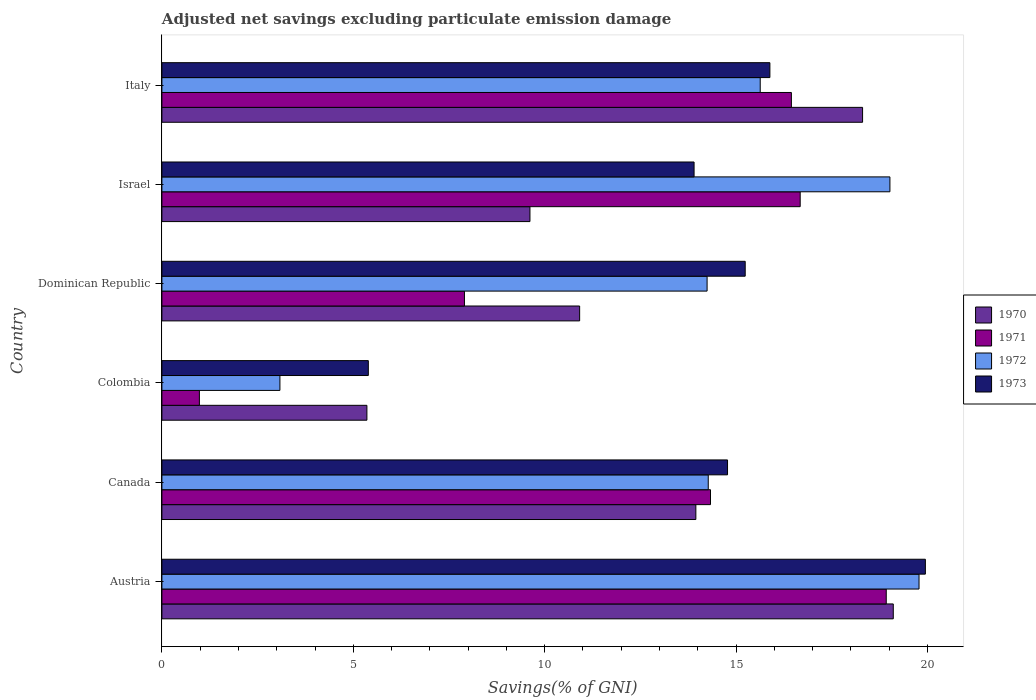How many different coloured bars are there?
Ensure brevity in your answer.  4. How many bars are there on the 3rd tick from the top?
Keep it short and to the point. 4. How many bars are there on the 1st tick from the bottom?
Keep it short and to the point. 4. What is the label of the 1st group of bars from the top?
Your response must be concise. Italy. In how many cases, is the number of bars for a given country not equal to the number of legend labels?
Your answer should be very brief. 0. What is the adjusted net savings in 1970 in Israel?
Make the answer very short. 9.61. Across all countries, what is the maximum adjusted net savings in 1972?
Offer a terse response. 19.78. Across all countries, what is the minimum adjusted net savings in 1972?
Offer a very short reply. 3.08. In which country was the adjusted net savings in 1971 maximum?
Your answer should be very brief. Austria. In which country was the adjusted net savings in 1972 minimum?
Your answer should be compact. Colombia. What is the total adjusted net savings in 1973 in the graph?
Make the answer very short. 85.14. What is the difference between the adjusted net savings in 1973 in Austria and that in Colombia?
Provide a short and direct response. 14.55. What is the difference between the adjusted net savings in 1971 in Dominican Republic and the adjusted net savings in 1972 in Israel?
Keep it short and to the point. -11.11. What is the average adjusted net savings in 1972 per country?
Make the answer very short. 14.34. What is the difference between the adjusted net savings in 1971 and adjusted net savings in 1970 in Austria?
Your response must be concise. -0.18. In how many countries, is the adjusted net savings in 1970 greater than 17 %?
Offer a terse response. 2. What is the ratio of the adjusted net savings in 1970 in Colombia to that in Dominican Republic?
Your answer should be compact. 0.49. Is the adjusted net savings in 1971 in Canada less than that in Israel?
Give a very brief answer. Yes. What is the difference between the highest and the second highest adjusted net savings in 1970?
Give a very brief answer. 0.8. What is the difference between the highest and the lowest adjusted net savings in 1973?
Offer a very short reply. 14.55. What does the 4th bar from the bottom in Austria represents?
Ensure brevity in your answer.  1973. Is it the case that in every country, the sum of the adjusted net savings in 1971 and adjusted net savings in 1972 is greater than the adjusted net savings in 1970?
Give a very brief answer. No. How many bars are there?
Your response must be concise. 24. Are the values on the major ticks of X-axis written in scientific E-notation?
Keep it short and to the point. No. Does the graph contain grids?
Offer a very short reply. No. How are the legend labels stacked?
Your answer should be compact. Vertical. What is the title of the graph?
Provide a short and direct response. Adjusted net savings excluding particulate emission damage. What is the label or title of the X-axis?
Your answer should be very brief. Savings(% of GNI). What is the label or title of the Y-axis?
Give a very brief answer. Country. What is the Savings(% of GNI) of 1970 in Austria?
Make the answer very short. 19.11. What is the Savings(% of GNI) in 1971 in Austria?
Keep it short and to the point. 18.92. What is the Savings(% of GNI) of 1972 in Austria?
Provide a short and direct response. 19.78. What is the Savings(% of GNI) of 1973 in Austria?
Ensure brevity in your answer.  19.94. What is the Savings(% of GNI) in 1970 in Canada?
Your answer should be very brief. 13.95. What is the Savings(% of GNI) in 1971 in Canada?
Give a very brief answer. 14.33. What is the Savings(% of GNI) in 1972 in Canada?
Keep it short and to the point. 14.27. What is the Savings(% of GNI) of 1973 in Canada?
Offer a very short reply. 14.78. What is the Savings(% of GNI) in 1970 in Colombia?
Ensure brevity in your answer.  5.36. What is the Savings(% of GNI) in 1971 in Colombia?
Keep it short and to the point. 0.98. What is the Savings(% of GNI) of 1972 in Colombia?
Your answer should be compact. 3.08. What is the Savings(% of GNI) of 1973 in Colombia?
Your response must be concise. 5.39. What is the Savings(% of GNI) in 1970 in Dominican Republic?
Offer a very short reply. 10.91. What is the Savings(% of GNI) of 1971 in Dominican Republic?
Your answer should be compact. 7.9. What is the Savings(% of GNI) in 1972 in Dominican Republic?
Offer a very short reply. 14.24. What is the Savings(% of GNI) in 1973 in Dominican Republic?
Your response must be concise. 15.24. What is the Savings(% of GNI) of 1970 in Israel?
Your response must be concise. 9.61. What is the Savings(% of GNI) of 1971 in Israel?
Offer a terse response. 16.67. What is the Savings(% of GNI) in 1972 in Israel?
Ensure brevity in your answer.  19.02. What is the Savings(% of GNI) in 1973 in Israel?
Your response must be concise. 13.9. What is the Savings(% of GNI) of 1970 in Italy?
Give a very brief answer. 18.3. What is the Savings(% of GNI) in 1971 in Italy?
Provide a short and direct response. 16.44. What is the Savings(% of GNI) in 1972 in Italy?
Make the answer very short. 15.63. What is the Savings(% of GNI) in 1973 in Italy?
Your response must be concise. 15.88. Across all countries, what is the maximum Savings(% of GNI) in 1970?
Give a very brief answer. 19.11. Across all countries, what is the maximum Savings(% of GNI) in 1971?
Give a very brief answer. 18.92. Across all countries, what is the maximum Savings(% of GNI) of 1972?
Your answer should be compact. 19.78. Across all countries, what is the maximum Savings(% of GNI) of 1973?
Give a very brief answer. 19.94. Across all countries, what is the minimum Savings(% of GNI) of 1970?
Keep it short and to the point. 5.36. Across all countries, what is the minimum Savings(% of GNI) in 1971?
Offer a terse response. 0.98. Across all countries, what is the minimum Savings(% of GNI) of 1972?
Your response must be concise. 3.08. Across all countries, what is the minimum Savings(% of GNI) of 1973?
Give a very brief answer. 5.39. What is the total Savings(% of GNI) of 1970 in the graph?
Your response must be concise. 77.24. What is the total Savings(% of GNI) of 1971 in the graph?
Provide a short and direct response. 75.25. What is the total Savings(% of GNI) in 1972 in the graph?
Make the answer very short. 86.02. What is the total Savings(% of GNI) in 1973 in the graph?
Keep it short and to the point. 85.14. What is the difference between the Savings(% of GNI) in 1970 in Austria and that in Canada?
Provide a short and direct response. 5.16. What is the difference between the Savings(% of GNI) in 1971 in Austria and that in Canada?
Provide a short and direct response. 4.59. What is the difference between the Savings(% of GNI) in 1972 in Austria and that in Canada?
Your answer should be compact. 5.51. What is the difference between the Savings(% of GNI) of 1973 in Austria and that in Canada?
Your answer should be compact. 5.17. What is the difference between the Savings(% of GNI) in 1970 in Austria and that in Colombia?
Your answer should be very brief. 13.75. What is the difference between the Savings(% of GNI) in 1971 in Austria and that in Colombia?
Offer a very short reply. 17.94. What is the difference between the Savings(% of GNI) of 1972 in Austria and that in Colombia?
Provide a short and direct response. 16.7. What is the difference between the Savings(% of GNI) of 1973 in Austria and that in Colombia?
Offer a terse response. 14.55. What is the difference between the Savings(% of GNI) of 1970 in Austria and that in Dominican Republic?
Provide a succinct answer. 8.19. What is the difference between the Savings(% of GNI) of 1971 in Austria and that in Dominican Republic?
Keep it short and to the point. 11.02. What is the difference between the Savings(% of GNI) in 1972 in Austria and that in Dominican Republic?
Ensure brevity in your answer.  5.54. What is the difference between the Savings(% of GNI) in 1973 in Austria and that in Dominican Republic?
Provide a short and direct response. 4.71. What is the difference between the Savings(% of GNI) of 1970 in Austria and that in Israel?
Offer a terse response. 9.49. What is the difference between the Savings(% of GNI) of 1971 in Austria and that in Israel?
Give a very brief answer. 2.25. What is the difference between the Savings(% of GNI) in 1972 in Austria and that in Israel?
Ensure brevity in your answer.  0.76. What is the difference between the Savings(% of GNI) in 1973 in Austria and that in Israel?
Ensure brevity in your answer.  6.04. What is the difference between the Savings(% of GNI) of 1970 in Austria and that in Italy?
Keep it short and to the point. 0.8. What is the difference between the Savings(% of GNI) of 1971 in Austria and that in Italy?
Your answer should be compact. 2.48. What is the difference between the Savings(% of GNI) in 1972 in Austria and that in Italy?
Offer a very short reply. 4.15. What is the difference between the Savings(% of GNI) of 1973 in Austria and that in Italy?
Your answer should be compact. 4.06. What is the difference between the Savings(% of GNI) in 1970 in Canada and that in Colombia?
Ensure brevity in your answer.  8.59. What is the difference between the Savings(% of GNI) in 1971 in Canada and that in Colombia?
Your answer should be compact. 13.35. What is the difference between the Savings(% of GNI) in 1972 in Canada and that in Colombia?
Keep it short and to the point. 11.19. What is the difference between the Savings(% of GNI) of 1973 in Canada and that in Colombia?
Provide a succinct answer. 9.38. What is the difference between the Savings(% of GNI) of 1970 in Canada and that in Dominican Republic?
Provide a short and direct response. 3.04. What is the difference between the Savings(% of GNI) of 1971 in Canada and that in Dominican Republic?
Keep it short and to the point. 6.43. What is the difference between the Savings(% of GNI) in 1972 in Canada and that in Dominican Republic?
Your answer should be very brief. 0.03. What is the difference between the Savings(% of GNI) in 1973 in Canada and that in Dominican Republic?
Your answer should be very brief. -0.46. What is the difference between the Savings(% of GNI) of 1970 in Canada and that in Israel?
Offer a terse response. 4.33. What is the difference between the Savings(% of GNI) in 1971 in Canada and that in Israel?
Provide a succinct answer. -2.34. What is the difference between the Savings(% of GNI) in 1972 in Canada and that in Israel?
Your response must be concise. -4.75. What is the difference between the Savings(% of GNI) in 1973 in Canada and that in Israel?
Provide a succinct answer. 0.87. What is the difference between the Savings(% of GNI) in 1970 in Canada and that in Italy?
Provide a short and direct response. -4.36. What is the difference between the Savings(% of GNI) of 1971 in Canada and that in Italy?
Your answer should be very brief. -2.11. What is the difference between the Savings(% of GNI) of 1972 in Canada and that in Italy?
Ensure brevity in your answer.  -1.36. What is the difference between the Savings(% of GNI) in 1973 in Canada and that in Italy?
Ensure brevity in your answer.  -1.11. What is the difference between the Savings(% of GNI) of 1970 in Colombia and that in Dominican Republic?
Provide a succinct answer. -5.56. What is the difference between the Savings(% of GNI) in 1971 in Colombia and that in Dominican Republic?
Keep it short and to the point. -6.92. What is the difference between the Savings(% of GNI) of 1972 in Colombia and that in Dominican Republic?
Your response must be concise. -11.16. What is the difference between the Savings(% of GNI) in 1973 in Colombia and that in Dominican Republic?
Ensure brevity in your answer.  -9.85. What is the difference between the Savings(% of GNI) in 1970 in Colombia and that in Israel?
Your answer should be compact. -4.26. What is the difference between the Savings(% of GNI) of 1971 in Colombia and that in Israel?
Your response must be concise. -15.7. What is the difference between the Savings(% of GNI) in 1972 in Colombia and that in Israel?
Provide a short and direct response. -15.94. What is the difference between the Savings(% of GNI) of 1973 in Colombia and that in Israel?
Ensure brevity in your answer.  -8.51. What is the difference between the Savings(% of GNI) in 1970 in Colombia and that in Italy?
Your response must be concise. -12.95. What is the difference between the Savings(% of GNI) of 1971 in Colombia and that in Italy?
Offer a terse response. -15.46. What is the difference between the Savings(% of GNI) of 1972 in Colombia and that in Italy?
Provide a short and direct response. -12.55. What is the difference between the Savings(% of GNI) in 1973 in Colombia and that in Italy?
Keep it short and to the point. -10.49. What is the difference between the Savings(% of GNI) in 1970 in Dominican Republic and that in Israel?
Provide a succinct answer. 1.3. What is the difference between the Savings(% of GNI) in 1971 in Dominican Republic and that in Israel?
Your answer should be very brief. -8.77. What is the difference between the Savings(% of GNI) of 1972 in Dominican Republic and that in Israel?
Make the answer very short. -4.78. What is the difference between the Savings(% of GNI) in 1973 in Dominican Republic and that in Israel?
Give a very brief answer. 1.34. What is the difference between the Savings(% of GNI) in 1970 in Dominican Republic and that in Italy?
Make the answer very short. -7.39. What is the difference between the Savings(% of GNI) of 1971 in Dominican Republic and that in Italy?
Your response must be concise. -8.54. What is the difference between the Savings(% of GNI) of 1972 in Dominican Republic and that in Italy?
Your answer should be compact. -1.39. What is the difference between the Savings(% of GNI) of 1973 in Dominican Republic and that in Italy?
Offer a terse response. -0.65. What is the difference between the Savings(% of GNI) in 1970 in Israel and that in Italy?
Provide a succinct answer. -8.69. What is the difference between the Savings(% of GNI) of 1971 in Israel and that in Italy?
Offer a terse response. 0.23. What is the difference between the Savings(% of GNI) in 1972 in Israel and that in Italy?
Offer a very short reply. 3.39. What is the difference between the Savings(% of GNI) in 1973 in Israel and that in Italy?
Provide a succinct answer. -1.98. What is the difference between the Savings(% of GNI) in 1970 in Austria and the Savings(% of GNI) in 1971 in Canada?
Your response must be concise. 4.77. What is the difference between the Savings(% of GNI) in 1970 in Austria and the Savings(% of GNI) in 1972 in Canada?
Your response must be concise. 4.83. What is the difference between the Savings(% of GNI) in 1970 in Austria and the Savings(% of GNI) in 1973 in Canada?
Offer a terse response. 4.33. What is the difference between the Savings(% of GNI) of 1971 in Austria and the Savings(% of GNI) of 1972 in Canada?
Provide a short and direct response. 4.65. What is the difference between the Savings(% of GNI) in 1971 in Austria and the Savings(% of GNI) in 1973 in Canada?
Make the answer very short. 4.15. What is the difference between the Savings(% of GNI) in 1972 in Austria and the Savings(% of GNI) in 1973 in Canada?
Give a very brief answer. 5. What is the difference between the Savings(% of GNI) of 1970 in Austria and the Savings(% of GNI) of 1971 in Colombia?
Your response must be concise. 18.13. What is the difference between the Savings(% of GNI) in 1970 in Austria and the Savings(% of GNI) in 1972 in Colombia?
Your response must be concise. 16.02. What is the difference between the Savings(% of GNI) of 1970 in Austria and the Savings(% of GNI) of 1973 in Colombia?
Offer a terse response. 13.71. What is the difference between the Savings(% of GNI) in 1971 in Austria and the Savings(% of GNI) in 1972 in Colombia?
Your answer should be very brief. 15.84. What is the difference between the Savings(% of GNI) of 1971 in Austria and the Savings(% of GNI) of 1973 in Colombia?
Give a very brief answer. 13.53. What is the difference between the Savings(% of GNI) in 1972 in Austria and the Savings(% of GNI) in 1973 in Colombia?
Provide a succinct answer. 14.39. What is the difference between the Savings(% of GNI) of 1970 in Austria and the Savings(% of GNI) of 1971 in Dominican Republic?
Provide a succinct answer. 11.2. What is the difference between the Savings(% of GNI) of 1970 in Austria and the Savings(% of GNI) of 1972 in Dominican Republic?
Make the answer very short. 4.86. What is the difference between the Savings(% of GNI) in 1970 in Austria and the Savings(% of GNI) in 1973 in Dominican Republic?
Your answer should be compact. 3.87. What is the difference between the Savings(% of GNI) in 1971 in Austria and the Savings(% of GNI) in 1972 in Dominican Republic?
Your answer should be compact. 4.68. What is the difference between the Savings(% of GNI) of 1971 in Austria and the Savings(% of GNI) of 1973 in Dominican Republic?
Offer a very short reply. 3.68. What is the difference between the Savings(% of GNI) in 1972 in Austria and the Savings(% of GNI) in 1973 in Dominican Republic?
Your answer should be very brief. 4.54. What is the difference between the Savings(% of GNI) of 1970 in Austria and the Savings(% of GNI) of 1971 in Israel?
Give a very brief answer. 2.43. What is the difference between the Savings(% of GNI) of 1970 in Austria and the Savings(% of GNI) of 1972 in Israel?
Give a very brief answer. 0.09. What is the difference between the Savings(% of GNI) in 1970 in Austria and the Savings(% of GNI) in 1973 in Israel?
Your response must be concise. 5.2. What is the difference between the Savings(% of GNI) of 1971 in Austria and the Savings(% of GNI) of 1972 in Israel?
Provide a succinct answer. -0.1. What is the difference between the Savings(% of GNI) in 1971 in Austria and the Savings(% of GNI) in 1973 in Israel?
Give a very brief answer. 5.02. What is the difference between the Savings(% of GNI) of 1972 in Austria and the Savings(% of GNI) of 1973 in Israel?
Your answer should be very brief. 5.88. What is the difference between the Savings(% of GNI) in 1970 in Austria and the Savings(% of GNI) in 1971 in Italy?
Offer a terse response. 2.66. What is the difference between the Savings(% of GNI) in 1970 in Austria and the Savings(% of GNI) in 1972 in Italy?
Provide a short and direct response. 3.48. What is the difference between the Savings(% of GNI) in 1970 in Austria and the Savings(% of GNI) in 1973 in Italy?
Make the answer very short. 3.22. What is the difference between the Savings(% of GNI) of 1971 in Austria and the Savings(% of GNI) of 1972 in Italy?
Give a very brief answer. 3.29. What is the difference between the Savings(% of GNI) in 1971 in Austria and the Savings(% of GNI) in 1973 in Italy?
Your answer should be very brief. 3.04. What is the difference between the Savings(% of GNI) in 1972 in Austria and the Savings(% of GNI) in 1973 in Italy?
Make the answer very short. 3.9. What is the difference between the Savings(% of GNI) in 1970 in Canada and the Savings(% of GNI) in 1971 in Colombia?
Give a very brief answer. 12.97. What is the difference between the Savings(% of GNI) in 1970 in Canada and the Savings(% of GNI) in 1972 in Colombia?
Offer a very short reply. 10.87. What is the difference between the Savings(% of GNI) of 1970 in Canada and the Savings(% of GNI) of 1973 in Colombia?
Offer a very short reply. 8.56. What is the difference between the Savings(% of GNI) in 1971 in Canada and the Savings(% of GNI) in 1972 in Colombia?
Offer a terse response. 11.25. What is the difference between the Savings(% of GNI) in 1971 in Canada and the Savings(% of GNI) in 1973 in Colombia?
Provide a succinct answer. 8.94. What is the difference between the Savings(% of GNI) of 1972 in Canada and the Savings(% of GNI) of 1973 in Colombia?
Make the answer very short. 8.88. What is the difference between the Savings(% of GNI) of 1970 in Canada and the Savings(% of GNI) of 1971 in Dominican Republic?
Your answer should be very brief. 6.05. What is the difference between the Savings(% of GNI) in 1970 in Canada and the Savings(% of GNI) in 1972 in Dominican Republic?
Provide a short and direct response. -0.29. What is the difference between the Savings(% of GNI) in 1970 in Canada and the Savings(% of GNI) in 1973 in Dominican Republic?
Keep it short and to the point. -1.29. What is the difference between the Savings(% of GNI) in 1971 in Canada and the Savings(% of GNI) in 1972 in Dominican Republic?
Your answer should be compact. 0.09. What is the difference between the Savings(% of GNI) in 1971 in Canada and the Savings(% of GNI) in 1973 in Dominican Republic?
Keep it short and to the point. -0.91. What is the difference between the Savings(% of GNI) of 1972 in Canada and the Savings(% of GNI) of 1973 in Dominican Republic?
Provide a succinct answer. -0.97. What is the difference between the Savings(% of GNI) in 1970 in Canada and the Savings(% of GNI) in 1971 in Israel?
Offer a very short reply. -2.73. What is the difference between the Savings(% of GNI) of 1970 in Canada and the Savings(% of GNI) of 1972 in Israel?
Ensure brevity in your answer.  -5.07. What is the difference between the Savings(% of GNI) in 1970 in Canada and the Savings(% of GNI) in 1973 in Israel?
Provide a succinct answer. 0.05. What is the difference between the Savings(% of GNI) of 1971 in Canada and the Savings(% of GNI) of 1972 in Israel?
Provide a succinct answer. -4.69. What is the difference between the Savings(% of GNI) in 1971 in Canada and the Savings(% of GNI) in 1973 in Israel?
Provide a short and direct response. 0.43. What is the difference between the Savings(% of GNI) in 1972 in Canada and the Savings(% of GNI) in 1973 in Israel?
Provide a succinct answer. 0.37. What is the difference between the Savings(% of GNI) of 1970 in Canada and the Savings(% of GNI) of 1971 in Italy?
Your answer should be very brief. -2.5. What is the difference between the Savings(% of GNI) in 1970 in Canada and the Savings(% of GNI) in 1972 in Italy?
Provide a succinct answer. -1.68. What is the difference between the Savings(% of GNI) in 1970 in Canada and the Savings(% of GNI) in 1973 in Italy?
Offer a very short reply. -1.93. What is the difference between the Savings(% of GNI) in 1971 in Canada and the Savings(% of GNI) in 1972 in Italy?
Offer a very short reply. -1.3. What is the difference between the Savings(% of GNI) in 1971 in Canada and the Savings(% of GNI) in 1973 in Italy?
Your response must be concise. -1.55. What is the difference between the Savings(% of GNI) of 1972 in Canada and the Savings(% of GNI) of 1973 in Italy?
Your answer should be very brief. -1.61. What is the difference between the Savings(% of GNI) of 1970 in Colombia and the Savings(% of GNI) of 1971 in Dominican Republic?
Your answer should be very brief. -2.55. What is the difference between the Savings(% of GNI) in 1970 in Colombia and the Savings(% of GNI) in 1972 in Dominican Republic?
Your answer should be compact. -8.89. What is the difference between the Savings(% of GNI) in 1970 in Colombia and the Savings(% of GNI) in 1973 in Dominican Republic?
Provide a short and direct response. -9.88. What is the difference between the Savings(% of GNI) of 1971 in Colombia and the Savings(% of GNI) of 1972 in Dominican Republic?
Make the answer very short. -13.26. What is the difference between the Savings(% of GNI) of 1971 in Colombia and the Savings(% of GNI) of 1973 in Dominican Republic?
Keep it short and to the point. -14.26. What is the difference between the Savings(% of GNI) of 1972 in Colombia and the Savings(% of GNI) of 1973 in Dominican Republic?
Offer a very short reply. -12.15. What is the difference between the Savings(% of GNI) of 1970 in Colombia and the Savings(% of GNI) of 1971 in Israel?
Offer a very short reply. -11.32. What is the difference between the Savings(% of GNI) of 1970 in Colombia and the Savings(% of GNI) of 1972 in Israel?
Provide a short and direct response. -13.66. What is the difference between the Savings(% of GNI) of 1970 in Colombia and the Savings(% of GNI) of 1973 in Israel?
Make the answer very short. -8.55. What is the difference between the Savings(% of GNI) of 1971 in Colombia and the Savings(% of GNI) of 1972 in Israel?
Give a very brief answer. -18.04. What is the difference between the Savings(% of GNI) in 1971 in Colombia and the Savings(% of GNI) in 1973 in Israel?
Your response must be concise. -12.92. What is the difference between the Savings(% of GNI) in 1972 in Colombia and the Savings(% of GNI) in 1973 in Israel?
Your answer should be compact. -10.82. What is the difference between the Savings(% of GNI) of 1970 in Colombia and the Savings(% of GNI) of 1971 in Italy?
Provide a short and direct response. -11.09. What is the difference between the Savings(% of GNI) of 1970 in Colombia and the Savings(% of GNI) of 1972 in Italy?
Provide a short and direct response. -10.27. What is the difference between the Savings(% of GNI) in 1970 in Colombia and the Savings(% of GNI) in 1973 in Italy?
Keep it short and to the point. -10.53. What is the difference between the Savings(% of GNI) of 1971 in Colombia and the Savings(% of GNI) of 1972 in Italy?
Make the answer very short. -14.65. What is the difference between the Savings(% of GNI) of 1971 in Colombia and the Savings(% of GNI) of 1973 in Italy?
Provide a short and direct response. -14.9. What is the difference between the Savings(% of GNI) of 1972 in Colombia and the Savings(% of GNI) of 1973 in Italy?
Keep it short and to the point. -12.8. What is the difference between the Savings(% of GNI) of 1970 in Dominican Republic and the Savings(% of GNI) of 1971 in Israel?
Your answer should be very brief. -5.76. What is the difference between the Savings(% of GNI) of 1970 in Dominican Republic and the Savings(% of GNI) of 1972 in Israel?
Provide a short and direct response. -8.11. What is the difference between the Savings(% of GNI) of 1970 in Dominican Republic and the Savings(% of GNI) of 1973 in Israel?
Give a very brief answer. -2.99. What is the difference between the Savings(% of GNI) of 1971 in Dominican Republic and the Savings(% of GNI) of 1972 in Israel?
Your answer should be very brief. -11.11. What is the difference between the Savings(% of GNI) in 1971 in Dominican Republic and the Savings(% of GNI) in 1973 in Israel?
Offer a terse response. -6. What is the difference between the Savings(% of GNI) in 1972 in Dominican Republic and the Savings(% of GNI) in 1973 in Israel?
Make the answer very short. 0.34. What is the difference between the Savings(% of GNI) in 1970 in Dominican Republic and the Savings(% of GNI) in 1971 in Italy?
Your answer should be very brief. -5.53. What is the difference between the Savings(% of GNI) in 1970 in Dominican Republic and the Savings(% of GNI) in 1972 in Italy?
Give a very brief answer. -4.72. What is the difference between the Savings(% of GNI) in 1970 in Dominican Republic and the Savings(% of GNI) in 1973 in Italy?
Provide a short and direct response. -4.97. What is the difference between the Savings(% of GNI) in 1971 in Dominican Republic and the Savings(% of GNI) in 1972 in Italy?
Keep it short and to the point. -7.73. What is the difference between the Savings(% of GNI) in 1971 in Dominican Republic and the Savings(% of GNI) in 1973 in Italy?
Make the answer very short. -7.98. What is the difference between the Savings(% of GNI) of 1972 in Dominican Republic and the Savings(% of GNI) of 1973 in Italy?
Your answer should be very brief. -1.64. What is the difference between the Savings(% of GNI) of 1970 in Israel and the Savings(% of GNI) of 1971 in Italy?
Your answer should be very brief. -6.83. What is the difference between the Savings(% of GNI) in 1970 in Israel and the Savings(% of GNI) in 1972 in Italy?
Ensure brevity in your answer.  -6.02. What is the difference between the Savings(% of GNI) of 1970 in Israel and the Savings(% of GNI) of 1973 in Italy?
Offer a very short reply. -6.27. What is the difference between the Savings(% of GNI) in 1971 in Israel and the Savings(% of GNI) in 1972 in Italy?
Ensure brevity in your answer.  1.04. What is the difference between the Savings(% of GNI) in 1971 in Israel and the Savings(% of GNI) in 1973 in Italy?
Your answer should be very brief. 0.79. What is the difference between the Savings(% of GNI) of 1972 in Israel and the Savings(% of GNI) of 1973 in Italy?
Offer a terse response. 3.14. What is the average Savings(% of GNI) of 1970 per country?
Your answer should be compact. 12.87. What is the average Savings(% of GNI) of 1971 per country?
Your answer should be compact. 12.54. What is the average Savings(% of GNI) of 1972 per country?
Give a very brief answer. 14.34. What is the average Savings(% of GNI) in 1973 per country?
Your answer should be compact. 14.19. What is the difference between the Savings(% of GNI) of 1970 and Savings(% of GNI) of 1971 in Austria?
Keep it short and to the point. 0.18. What is the difference between the Savings(% of GNI) in 1970 and Savings(% of GNI) in 1972 in Austria?
Your answer should be compact. -0.67. What is the difference between the Savings(% of GNI) of 1970 and Savings(% of GNI) of 1973 in Austria?
Give a very brief answer. -0.84. What is the difference between the Savings(% of GNI) in 1971 and Savings(% of GNI) in 1972 in Austria?
Provide a short and direct response. -0.86. What is the difference between the Savings(% of GNI) of 1971 and Savings(% of GNI) of 1973 in Austria?
Make the answer very short. -1.02. What is the difference between the Savings(% of GNI) of 1972 and Savings(% of GNI) of 1973 in Austria?
Make the answer very short. -0.17. What is the difference between the Savings(% of GNI) of 1970 and Savings(% of GNI) of 1971 in Canada?
Make the answer very short. -0.38. What is the difference between the Savings(% of GNI) of 1970 and Savings(% of GNI) of 1972 in Canada?
Provide a succinct answer. -0.32. What is the difference between the Savings(% of GNI) of 1970 and Savings(% of GNI) of 1973 in Canada?
Provide a succinct answer. -0.83. What is the difference between the Savings(% of GNI) of 1971 and Savings(% of GNI) of 1972 in Canada?
Ensure brevity in your answer.  0.06. What is the difference between the Savings(% of GNI) in 1971 and Savings(% of GNI) in 1973 in Canada?
Your response must be concise. -0.45. What is the difference between the Savings(% of GNI) in 1972 and Savings(% of GNI) in 1973 in Canada?
Make the answer very short. -0.5. What is the difference between the Savings(% of GNI) of 1970 and Savings(% of GNI) of 1971 in Colombia?
Offer a very short reply. 4.38. What is the difference between the Savings(% of GNI) in 1970 and Savings(% of GNI) in 1972 in Colombia?
Keep it short and to the point. 2.27. What is the difference between the Savings(% of GNI) of 1970 and Savings(% of GNI) of 1973 in Colombia?
Offer a very short reply. -0.04. What is the difference between the Savings(% of GNI) in 1971 and Savings(% of GNI) in 1972 in Colombia?
Keep it short and to the point. -2.1. What is the difference between the Savings(% of GNI) of 1971 and Savings(% of GNI) of 1973 in Colombia?
Keep it short and to the point. -4.41. What is the difference between the Savings(% of GNI) in 1972 and Savings(% of GNI) in 1973 in Colombia?
Your answer should be very brief. -2.31. What is the difference between the Savings(% of GNI) in 1970 and Savings(% of GNI) in 1971 in Dominican Republic?
Provide a short and direct response. 3.01. What is the difference between the Savings(% of GNI) of 1970 and Savings(% of GNI) of 1972 in Dominican Republic?
Make the answer very short. -3.33. What is the difference between the Savings(% of GNI) of 1970 and Savings(% of GNI) of 1973 in Dominican Republic?
Your answer should be compact. -4.33. What is the difference between the Savings(% of GNI) of 1971 and Savings(% of GNI) of 1972 in Dominican Republic?
Your answer should be compact. -6.34. What is the difference between the Savings(% of GNI) in 1971 and Savings(% of GNI) in 1973 in Dominican Republic?
Keep it short and to the point. -7.33. What is the difference between the Savings(% of GNI) in 1972 and Savings(% of GNI) in 1973 in Dominican Republic?
Provide a succinct answer. -1. What is the difference between the Savings(% of GNI) in 1970 and Savings(% of GNI) in 1971 in Israel?
Offer a terse response. -7.06. What is the difference between the Savings(% of GNI) in 1970 and Savings(% of GNI) in 1972 in Israel?
Offer a terse response. -9.4. What is the difference between the Savings(% of GNI) in 1970 and Savings(% of GNI) in 1973 in Israel?
Ensure brevity in your answer.  -4.29. What is the difference between the Savings(% of GNI) of 1971 and Savings(% of GNI) of 1972 in Israel?
Ensure brevity in your answer.  -2.34. What is the difference between the Savings(% of GNI) in 1971 and Savings(% of GNI) in 1973 in Israel?
Ensure brevity in your answer.  2.77. What is the difference between the Savings(% of GNI) in 1972 and Savings(% of GNI) in 1973 in Israel?
Provide a short and direct response. 5.12. What is the difference between the Savings(% of GNI) of 1970 and Savings(% of GNI) of 1971 in Italy?
Your response must be concise. 1.86. What is the difference between the Savings(% of GNI) in 1970 and Savings(% of GNI) in 1972 in Italy?
Your answer should be compact. 2.67. What is the difference between the Savings(% of GNI) in 1970 and Savings(% of GNI) in 1973 in Italy?
Your response must be concise. 2.42. What is the difference between the Savings(% of GNI) of 1971 and Savings(% of GNI) of 1972 in Italy?
Give a very brief answer. 0.81. What is the difference between the Savings(% of GNI) in 1971 and Savings(% of GNI) in 1973 in Italy?
Make the answer very short. 0.56. What is the difference between the Savings(% of GNI) of 1972 and Savings(% of GNI) of 1973 in Italy?
Ensure brevity in your answer.  -0.25. What is the ratio of the Savings(% of GNI) in 1970 in Austria to that in Canada?
Your answer should be very brief. 1.37. What is the ratio of the Savings(% of GNI) of 1971 in Austria to that in Canada?
Your response must be concise. 1.32. What is the ratio of the Savings(% of GNI) in 1972 in Austria to that in Canada?
Offer a very short reply. 1.39. What is the ratio of the Savings(% of GNI) of 1973 in Austria to that in Canada?
Your answer should be very brief. 1.35. What is the ratio of the Savings(% of GNI) in 1970 in Austria to that in Colombia?
Offer a very short reply. 3.57. What is the ratio of the Savings(% of GNI) in 1971 in Austria to that in Colombia?
Keep it short and to the point. 19.32. What is the ratio of the Savings(% of GNI) in 1972 in Austria to that in Colombia?
Offer a terse response. 6.42. What is the ratio of the Savings(% of GNI) in 1973 in Austria to that in Colombia?
Offer a very short reply. 3.7. What is the ratio of the Savings(% of GNI) in 1970 in Austria to that in Dominican Republic?
Your answer should be compact. 1.75. What is the ratio of the Savings(% of GNI) in 1971 in Austria to that in Dominican Republic?
Ensure brevity in your answer.  2.39. What is the ratio of the Savings(% of GNI) in 1972 in Austria to that in Dominican Republic?
Provide a succinct answer. 1.39. What is the ratio of the Savings(% of GNI) of 1973 in Austria to that in Dominican Republic?
Provide a succinct answer. 1.31. What is the ratio of the Savings(% of GNI) in 1970 in Austria to that in Israel?
Your answer should be compact. 1.99. What is the ratio of the Savings(% of GNI) of 1971 in Austria to that in Israel?
Ensure brevity in your answer.  1.13. What is the ratio of the Savings(% of GNI) in 1972 in Austria to that in Israel?
Your answer should be very brief. 1.04. What is the ratio of the Savings(% of GNI) in 1973 in Austria to that in Israel?
Ensure brevity in your answer.  1.43. What is the ratio of the Savings(% of GNI) in 1970 in Austria to that in Italy?
Provide a succinct answer. 1.04. What is the ratio of the Savings(% of GNI) of 1971 in Austria to that in Italy?
Keep it short and to the point. 1.15. What is the ratio of the Savings(% of GNI) in 1972 in Austria to that in Italy?
Provide a short and direct response. 1.27. What is the ratio of the Savings(% of GNI) in 1973 in Austria to that in Italy?
Your answer should be very brief. 1.26. What is the ratio of the Savings(% of GNI) of 1970 in Canada to that in Colombia?
Your answer should be very brief. 2.6. What is the ratio of the Savings(% of GNI) in 1971 in Canada to that in Colombia?
Your answer should be very brief. 14.64. What is the ratio of the Savings(% of GNI) of 1972 in Canada to that in Colombia?
Make the answer very short. 4.63. What is the ratio of the Savings(% of GNI) of 1973 in Canada to that in Colombia?
Provide a short and direct response. 2.74. What is the ratio of the Savings(% of GNI) in 1970 in Canada to that in Dominican Republic?
Keep it short and to the point. 1.28. What is the ratio of the Savings(% of GNI) of 1971 in Canada to that in Dominican Republic?
Your answer should be very brief. 1.81. What is the ratio of the Savings(% of GNI) in 1973 in Canada to that in Dominican Republic?
Offer a terse response. 0.97. What is the ratio of the Savings(% of GNI) of 1970 in Canada to that in Israel?
Provide a succinct answer. 1.45. What is the ratio of the Savings(% of GNI) in 1971 in Canada to that in Israel?
Provide a short and direct response. 0.86. What is the ratio of the Savings(% of GNI) in 1972 in Canada to that in Israel?
Offer a terse response. 0.75. What is the ratio of the Savings(% of GNI) in 1973 in Canada to that in Israel?
Offer a very short reply. 1.06. What is the ratio of the Savings(% of GNI) in 1970 in Canada to that in Italy?
Offer a terse response. 0.76. What is the ratio of the Savings(% of GNI) in 1971 in Canada to that in Italy?
Your answer should be very brief. 0.87. What is the ratio of the Savings(% of GNI) of 1972 in Canada to that in Italy?
Your response must be concise. 0.91. What is the ratio of the Savings(% of GNI) of 1973 in Canada to that in Italy?
Offer a very short reply. 0.93. What is the ratio of the Savings(% of GNI) of 1970 in Colombia to that in Dominican Republic?
Your answer should be compact. 0.49. What is the ratio of the Savings(% of GNI) of 1971 in Colombia to that in Dominican Republic?
Offer a very short reply. 0.12. What is the ratio of the Savings(% of GNI) of 1972 in Colombia to that in Dominican Republic?
Keep it short and to the point. 0.22. What is the ratio of the Savings(% of GNI) of 1973 in Colombia to that in Dominican Republic?
Your answer should be very brief. 0.35. What is the ratio of the Savings(% of GNI) in 1970 in Colombia to that in Israel?
Make the answer very short. 0.56. What is the ratio of the Savings(% of GNI) in 1971 in Colombia to that in Israel?
Your response must be concise. 0.06. What is the ratio of the Savings(% of GNI) in 1972 in Colombia to that in Israel?
Ensure brevity in your answer.  0.16. What is the ratio of the Savings(% of GNI) of 1973 in Colombia to that in Israel?
Offer a very short reply. 0.39. What is the ratio of the Savings(% of GNI) of 1970 in Colombia to that in Italy?
Keep it short and to the point. 0.29. What is the ratio of the Savings(% of GNI) in 1971 in Colombia to that in Italy?
Provide a short and direct response. 0.06. What is the ratio of the Savings(% of GNI) of 1972 in Colombia to that in Italy?
Your answer should be very brief. 0.2. What is the ratio of the Savings(% of GNI) in 1973 in Colombia to that in Italy?
Give a very brief answer. 0.34. What is the ratio of the Savings(% of GNI) in 1970 in Dominican Republic to that in Israel?
Your answer should be compact. 1.14. What is the ratio of the Savings(% of GNI) in 1971 in Dominican Republic to that in Israel?
Make the answer very short. 0.47. What is the ratio of the Savings(% of GNI) in 1972 in Dominican Republic to that in Israel?
Make the answer very short. 0.75. What is the ratio of the Savings(% of GNI) of 1973 in Dominican Republic to that in Israel?
Ensure brevity in your answer.  1.1. What is the ratio of the Savings(% of GNI) of 1970 in Dominican Republic to that in Italy?
Make the answer very short. 0.6. What is the ratio of the Savings(% of GNI) of 1971 in Dominican Republic to that in Italy?
Keep it short and to the point. 0.48. What is the ratio of the Savings(% of GNI) in 1972 in Dominican Republic to that in Italy?
Offer a very short reply. 0.91. What is the ratio of the Savings(% of GNI) in 1973 in Dominican Republic to that in Italy?
Make the answer very short. 0.96. What is the ratio of the Savings(% of GNI) in 1970 in Israel to that in Italy?
Offer a terse response. 0.53. What is the ratio of the Savings(% of GNI) in 1972 in Israel to that in Italy?
Make the answer very short. 1.22. What is the ratio of the Savings(% of GNI) in 1973 in Israel to that in Italy?
Make the answer very short. 0.88. What is the difference between the highest and the second highest Savings(% of GNI) of 1970?
Keep it short and to the point. 0.8. What is the difference between the highest and the second highest Savings(% of GNI) of 1971?
Your response must be concise. 2.25. What is the difference between the highest and the second highest Savings(% of GNI) in 1972?
Your answer should be very brief. 0.76. What is the difference between the highest and the second highest Savings(% of GNI) of 1973?
Your answer should be compact. 4.06. What is the difference between the highest and the lowest Savings(% of GNI) in 1970?
Offer a very short reply. 13.75. What is the difference between the highest and the lowest Savings(% of GNI) of 1971?
Your response must be concise. 17.94. What is the difference between the highest and the lowest Savings(% of GNI) in 1972?
Provide a short and direct response. 16.7. What is the difference between the highest and the lowest Savings(% of GNI) of 1973?
Ensure brevity in your answer.  14.55. 